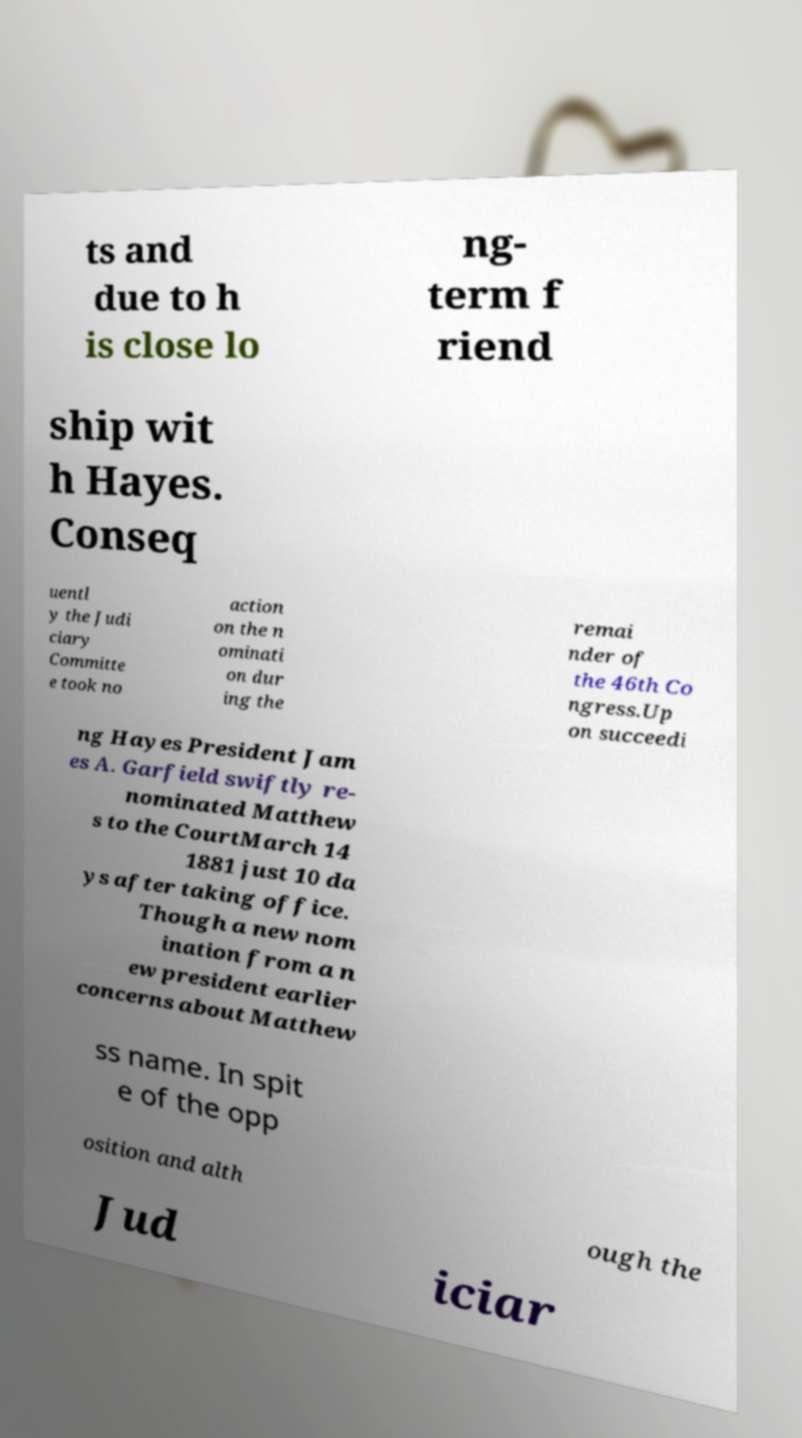There's text embedded in this image that I need extracted. Can you transcribe it verbatim? ts and due to h is close lo ng- term f riend ship wit h Hayes. Conseq uentl y the Judi ciary Committe e took no action on the n ominati on dur ing the remai nder of the 46th Co ngress.Up on succeedi ng Hayes President Jam es A. Garfield swiftly re- nominated Matthew s to the CourtMarch 14 1881 just 10 da ys after taking office. Though a new nom ination from a n ew president earlier concerns about Matthew ss name. In spit e of the opp osition and alth ough the Jud iciar 